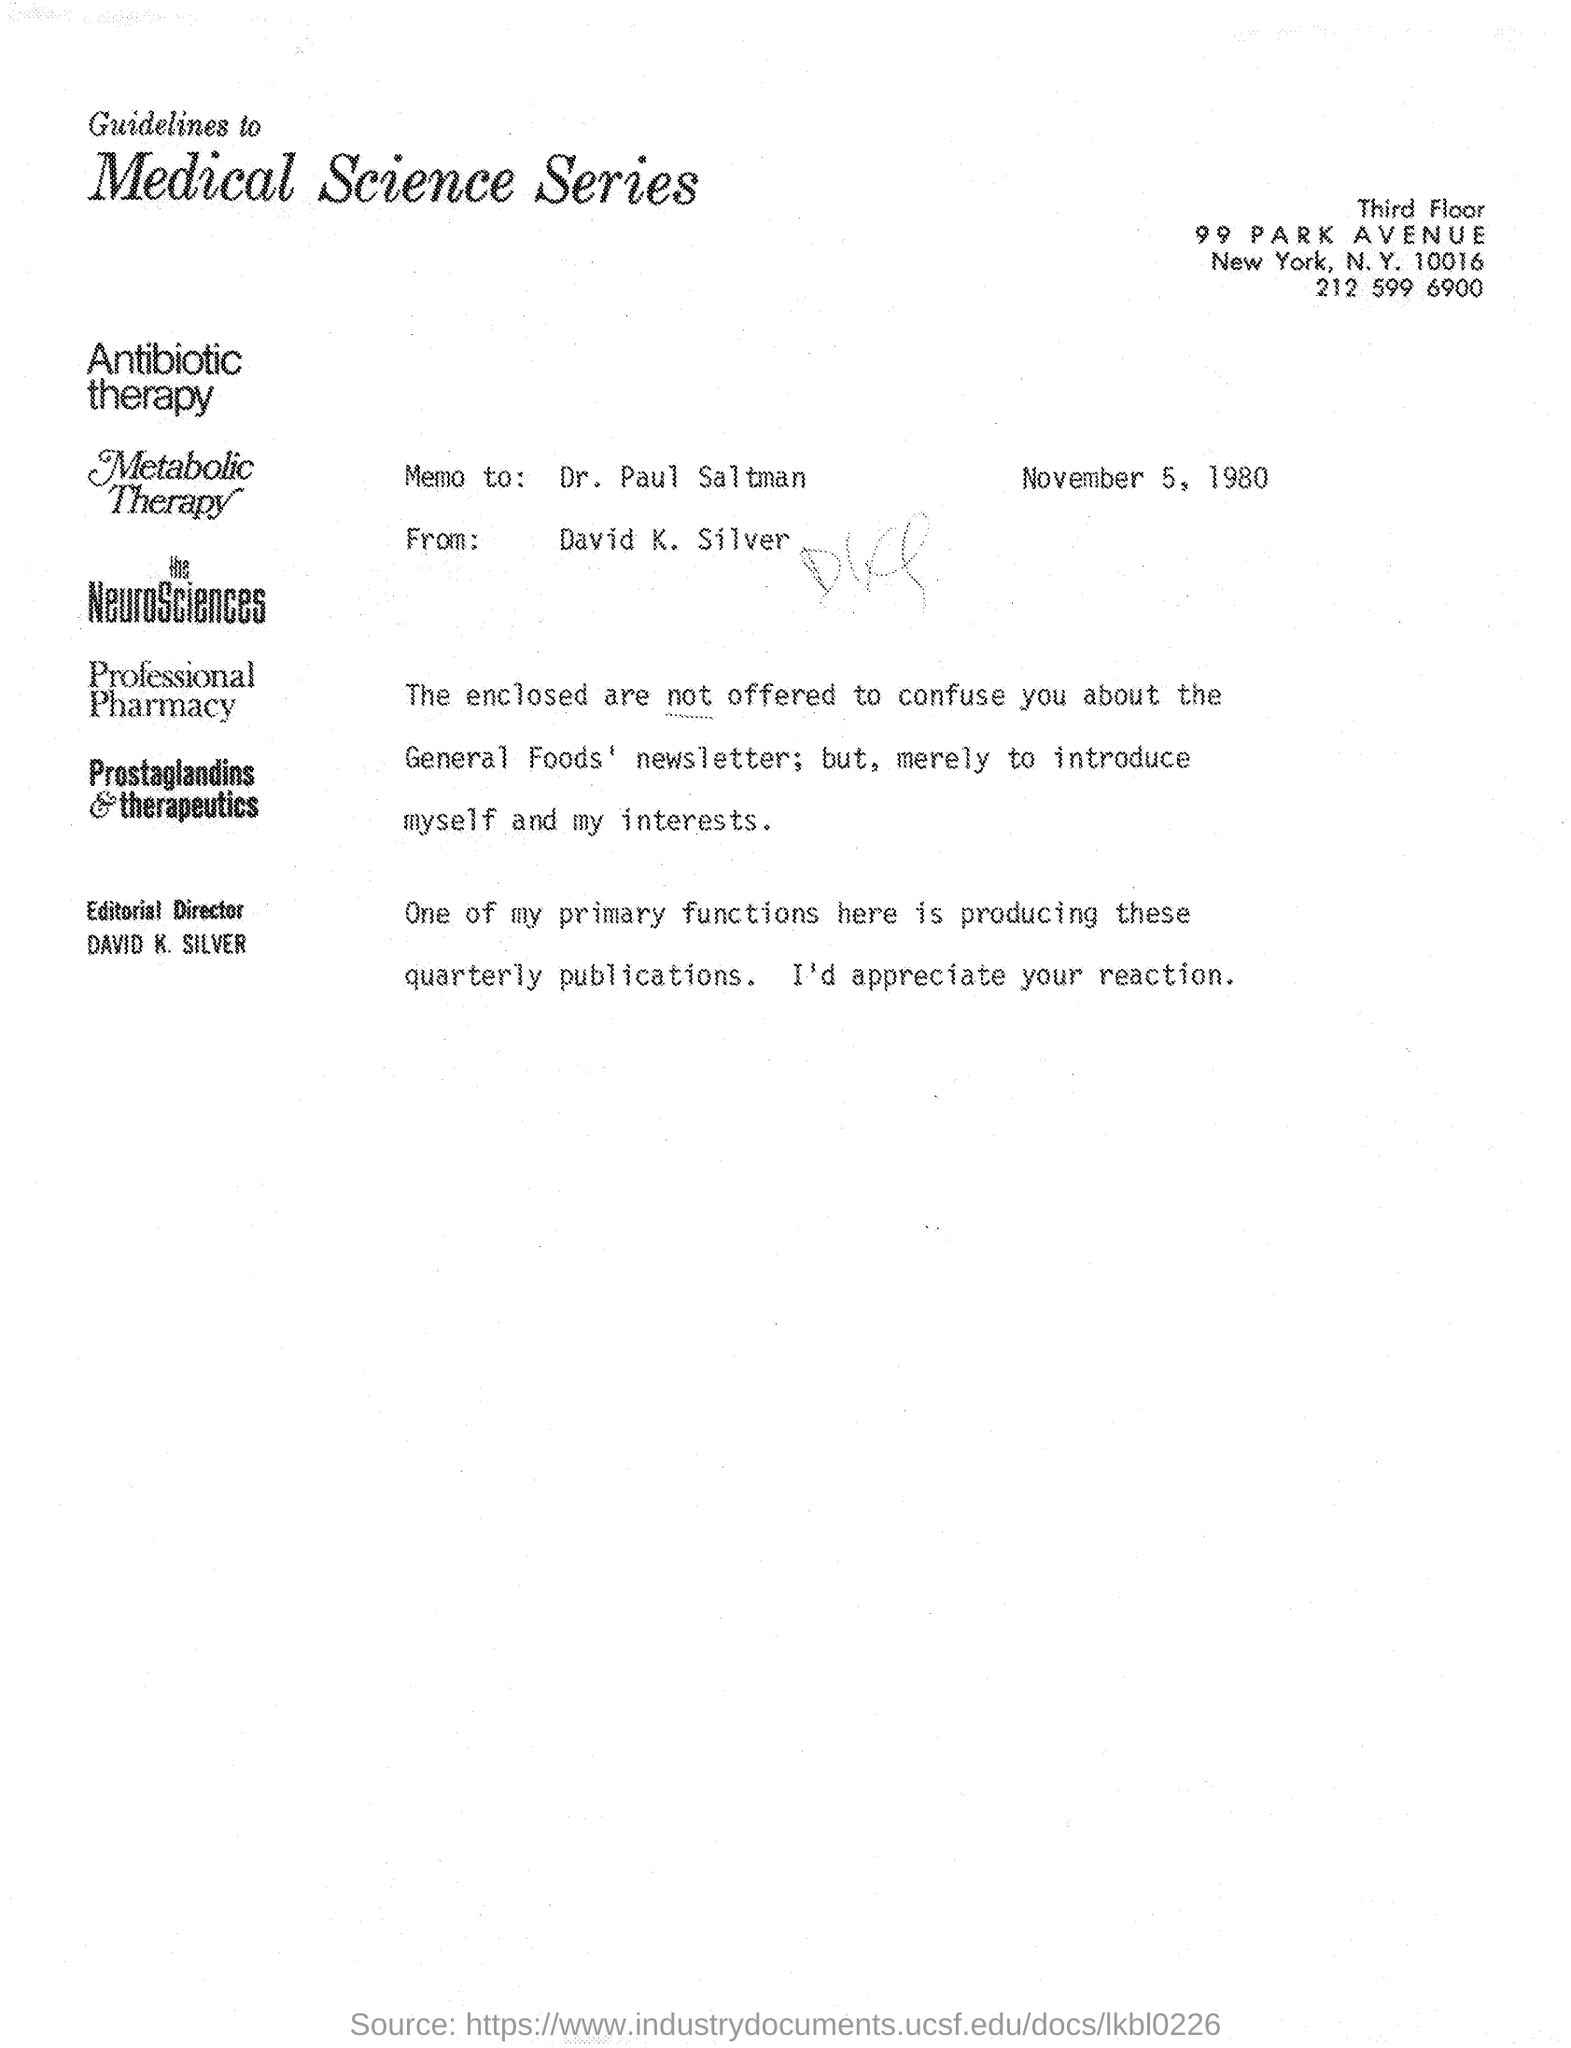To whom the memo was given as mentioned in the given page ?
Make the answer very short. Dr. Paul Saltman. From whom the memo was received ?
Make the answer very short. David K. Silver. What is the date mentioned in the given page ?
Give a very brief answer. November 5, 1980. What is the name of editorial director as mentioned in the given page ?
Provide a succinct answer. David K. Silver. 